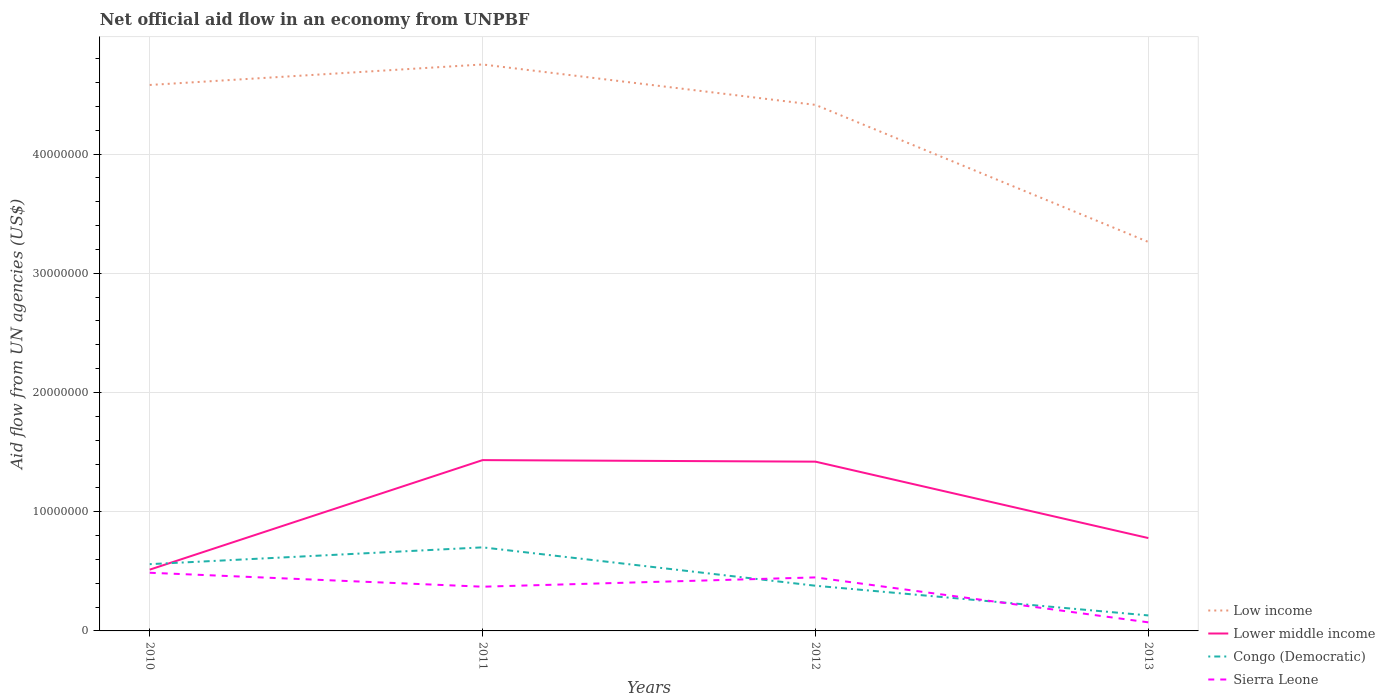Does the line corresponding to Lower middle income intersect with the line corresponding to Congo (Democratic)?
Your answer should be very brief. Yes. Is the number of lines equal to the number of legend labels?
Give a very brief answer. Yes. Across all years, what is the maximum net official aid flow in Sierra Leone?
Ensure brevity in your answer.  7.20e+05. What is the total net official aid flow in Lower middle income in the graph?
Provide a succinct answer. 6.54e+06. What is the difference between the highest and the second highest net official aid flow in Congo (Democratic)?
Offer a very short reply. 5.71e+06. Does the graph contain any zero values?
Provide a short and direct response. No. Does the graph contain grids?
Ensure brevity in your answer.  Yes. How many legend labels are there?
Offer a very short reply. 4. What is the title of the graph?
Provide a short and direct response. Net official aid flow in an economy from UNPBF. What is the label or title of the Y-axis?
Provide a short and direct response. Aid flow from UN agencies (US$). What is the Aid flow from UN agencies (US$) in Low income in 2010?
Make the answer very short. 4.58e+07. What is the Aid flow from UN agencies (US$) of Lower middle income in 2010?
Your response must be concise. 5.14e+06. What is the Aid flow from UN agencies (US$) in Congo (Democratic) in 2010?
Keep it short and to the point. 5.60e+06. What is the Aid flow from UN agencies (US$) in Sierra Leone in 2010?
Keep it short and to the point. 4.88e+06. What is the Aid flow from UN agencies (US$) of Low income in 2011?
Provide a short and direct response. 4.75e+07. What is the Aid flow from UN agencies (US$) of Lower middle income in 2011?
Ensure brevity in your answer.  1.43e+07. What is the Aid flow from UN agencies (US$) in Congo (Democratic) in 2011?
Provide a short and direct response. 7.01e+06. What is the Aid flow from UN agencies (US$) in Sierra Leone in 2011?
Offer a very short reply. 3.71e+06. What is the Aid flow from UN agencies (US$) of Low income in 2012?
Keep it short and to the point. 4.41e+07. What is the Aid flow from UN agencies (US$) in Lower middle income in 2012?
Provide a short and direct response. 1.42e+07. What is the Aid flow from UN agencies (US$) in Congo (Democratic) in 2012?
Offer a terse response. 3.79e+06. What is the Aid flow from UN agencies (US$) in Sierra Leone in 2012?
Offer a terse response. 4.49e+06. What is the Aid flow from UN agencies (US$) of Low income in 2013?
Your response must be concise. 3.26e+07. What is the Aid flow from UN agencies (US$) of Lower middle income in 2013?
Your response must be concise. 7.79e+06. What is the Aid flow from UN agencies (US$) of Congo (Democratic) in 2013?
Provide a succinct answer. 1.30e+06. What is the Aid flow from UN agencies (US$) of Sierra Leone in 2013?
Give a very brief answer. 7.20e+05. Across all years, what is the maximum Aid flow from UN agencies (US$) of Low income?
Your answer should be compact. 4.75e+07. Across all years, what is the maximum Aid flow from UN agencies (US$) of Lower middle income?
Your answer should be very brief. 1.43e+07. Across all years, what is the maximum Aid flow from UN agencies (US$) of Congo (Democratic)?
Your answer should be very brief. 7.01e+06. Across all years, what is the maximum Aid flow from UN agencies (US$) in Sierra Leone?
Offer a terse response. 4.88e+06. Across all years, what is the minimum Aid flow from UN agencies (US$) in Low income?
Keep it short and to the point. 3.26e+07. Across all years, what is the minimum Aid flow from UN agencies (US$) of Lower middle income?
Give a very brief answer. 5.14e+06. Across all years, what is the minimum Aid flow from UN agencies (US$) in Congo (Democratic)?
Provide a short and direct response. 1.30e+06. Across all years, what is the minimum Aid flow from UN agencies (US$) of Sierra Leone?
Offer a very short reply. 7.20e+05. What is the total Aid flow from UN agencies (US$) of Low income in the graph?
Keep it short and to the point. 1.70e+08. What is the total Aid flow from UN agencies (US$) in Lower middle income in the graph?
Give a very brief answer. 4.15e+07. What is the total Aid flow from UN agencies (US$) in Congo (Democratic) in the graph?
Give a very brief answer. 1.77e+07. What is the total Aid flow from UN agencies (US$) of Sierra Leone in the graph?
Give a very brief answer. 1.38e+07. What is the difference between the Aid flow from UN agencies (US$) in Low income in 2010 and that in 2011?
Your response must be concise. -1.72e+06. What is the difference between the Aid flow from UN agencies (US$) of Lower middle income in 2010 and that in 2011?
Provide a short and direct response. -9.19e+06. What is the difference between the Aid flow from UN agencies (US$) of Congo (Democratic) in 2010 and that in 2011?
Offer a terse response. -1.41e+06. What is the difference between the Aid flow from UN agencies (US$) in Sierra Leone in 2010 and that in 2011?
Your answer should be compact. 1.17e+06. What is the difference between the Aid flow from UN agencies (US$) of Low income in 2010 and that in 2012?
Ensure brevity in your answer.  1.67e+06. What is the difference between the Aid flow from UN agencies (US$) in Lower middle income in 2010 and that in 2012?
Keep it short and to the point. -9.06e+06. What is the difference between the Aid flow from UN agencies (US$) of Congo (Democratic) in 2010 and that in 2012?
Offer a terse response. 1.81e+06. What is the difference between the Aid flow from UN agencies (US$) in Low income in 2010 and that in 2013?
Offer a very short reply. 1.32e+07. What is the difference between the Aid flow from UN agencies (US$) of Lower middle income in 2010 and that in 2013?
Your response must be concise. -2.65e+06. What is the difference between the Aid flow from UN agencies (US$) in Congo (Democratic) in 2010 and that in 2013?
Offer a terse response. 4.30e+06. What is the difference between the Aid flow from UN agencies (US$) of Sierra Leone in 2010 and that in 2013?
Your answer should be compact. 4.16e+06. What is the difference between the Aid flow from UN agencies (US$) in Low income in 2011 and that in 2012?
Offer a terse response. 3.39e+06. What is the difference between the Aid flow from UN agencies (US$) of Lower middle income in 2011 and that in 2012?
Provide a succinct answer. 1.30e+05. What is the difference between the Aid flow from UN agencies (US$) in Congo (Democratic) in 2011 and that in 2012?
Give a very brief answer. 3.22e+06. What is the difference between the Aid flow from UN agencies (US$) in Sierra Leone in 2011 and that in 2012?
Your answer should be very brief. -7.80e+05. What is the difference between the Aid flow from UN agencies (US$) of Low income in 2011 and that in 2013?
Your answer should be very brief. 1.49e+07. What is the difference between the Aid flow from UN agencies (US$) of Lower middle income in 2011 and that in 2013?
Ensure brevity in your answer.  6.54e+06. What is the difference between the Aid flow from UN agencies (US$) in Congo (Democratic) in 2011 and that in 2013?
Provide a short and direct response. 5.71e+06. What is the difference between the Aid flow from UN agencies (US$) in Sierra Leone in 2011 and that in 2013?
Your response must be concise. 2.99e+06. What is the difference between the Aid flow from UN agencies (US$) of Low income in 2012 and that in 2013?
Make the answer very short. 1.15e+07. What is the difference between the Aid flow from UN agencies (US$) of Lower middle income in 2012 and that in 2013?
Offer a terse response. 6.41e+06. What is the difference between the Aid flow from UN agencies (US$) in Congo (Democratic) in 2012 and that in 2013?
Offer a very short reply. 2.49e+06. What is the difference between the Aid flow from UN agencies (US$) of Sierra Leone in 2012 and that in 2013?
Provide a short and direct response. 3.77e+06. What is the difference between the Aid flow from UN agencies (US$) of Low income in 2010 and the Aid flow from UN agencies (US$) of Lower middle income in 2011?
Your answer should be compact. 3.15e+07. What is the difference between the Aid flow from UN agencies (US$) in Low income in 2010 and the Aid flow from UN agencies (US$) in Congo (Democratic) in 2011?
Keep it short and to the point. 3.88e+07. What is the difference between the Aid flow from UN agencies (US$) in Low income in 2010 and the Aid flow from UN agencies (US$) in Sierra Leone in 2011?
Offer a terse response. 4.21e+07. What is the difference between the Aid flow from UN agencies (US$) in Lower middle income in 2010 and the Aid flow from UN agencies (US$) in Congo (Democratic) in 2011?
Make the answer very short. -1.87e+06. What is the difference between the Aid flow from UN agencies (US$) in Lower middle income in 2010 and the Aid flow from UN agencies (US$) in Sierra Leone in 2011?
Offer a terse response. 1.43e+06. What is the difference between the Aid flow from UN agencies (US$) in Congo (Democratic) in 2010 and the Aid flow from UN agencies (US$) in Sierra Leone in 2011?
Ensure brevity in your answer.  1.89e+06. What is the difference between the Aid flow from UN agencies (US$) of Low income in 2010 and the Aid flow from UN agencies (US$) of Lower middle income in 2012?
Give a very brief answer. 3.16e+07. What is the difference between the Aid flow from UN agencies (US$) of Low income in 2010 and the Aid flow from UN agencies (US$) of Congo (Democratic) in 2012?
Make the answer very short. 4.20e+07. What is the difference between the Aid flow from UN agencies (US$) of Low income in 2010 and the Aid flow from UN agencies (US$) of Sierra Leone in 2012?
Ensure brevity in your answer.  4.13e+07. What is the difference between the Aid flow from UN agencies (US$) of Lower middle income in 2010 and the Aid flow from UN agencies (US$) of Congo (Democratic) in 2012?
Make the answer very short. 1.35e+06. What is the difference between the Aid flow from UN agencies (US$) in Lower middle income in 2010 and the Aid flow from UN agencies (US$) in Sierra Leone in 2012?
Your answer should be compact. 6.50e+05. What is the difference between the Aid flow from UN agencies (US$) in Congo (Democratic) in 2010 and the Aid flow from UN agencies (US$) in Sierra Leone in 2012?
Your answer should be compact. 1.11e+06. What is the difference between the Aid flow from UN agencies (US$) in Low income in 2010 and the Aid flow from UN agencies (US$) in Lower middle income in 2013?
Provide a short and direct response. 3.80e+07. What is the difference between the Aid flow from UN agencies (US$) in Low income in 2010 and the Aid flow from UN agencies (US$) in Congo (Democratic) in 2013?
Your answer should be compact. 4.45e+07. What is the difference between the Aid flow from UN agencies (US$) in Low income in 2010 and the Aid flow from UN agencies (US$) in Sierra Leone in 2013?
Give a very brief answer. 4.51e+07. What is the difference between the Aid flow from UN agencies (US$) in Lower middle income in 2010 and the Aid flow from UN agencies (US$) in Congo (Democratic) in 2013?
Give a very brief answer. 3.84e+06. What is the difference between the Aid flow from UN agencies (US$) of Lower middle income in 2010 and the Aid flow from UN agencies (US$) of Sierra Leone in 2013?
Provide a short and direct response. 4.42e+06. What is the difference between the Aid flow from UN agencies (US$) in Congo (Democratic) in 2010 and the Aid flow from UN agencies (US$) in Sierra Leone in 2013?
Your answer should be compact. 4.88e+06. What is the difference between the Aid flow from UN agencies (US$) of Low income in 2011 and the Aid flow from UN agencies (US$) of Lower middle income in 2012?
Your answer should be compact. 3.33e+07. What is the difference between the Aid flow from UN agencies (US$) in Low income in 2011 and the Aid flow from UN agencies (US$) in Congo (Democratic) in 2012?
Ensure brevity in your answer.  4.37e+07. What is the difference between the Aid flow from UN agencies (US$) of Low income in 2011 and the Aid flow from UN agencies (US$) of Sierra Leone in 2012?
Ensure brevity in your answer.  4.30e+07. What is the difference between the Aid flow from UN agencies (US$) of Lower middle income in 2011 and the Aid flow from UN agencies (US$) of Congo (Democratic) in 2012?
Offer a terse response. 1.05e+07. What is the difference between the Aid flow from UN agencies (US$) in Lower middle income in 2011 and the Aid flow from UN agencies (US$) in Sierra Leone in 2012?
Ensure brevity in your answer.  9.84e+06. What is the difference between the Aid flow from UN agencies (US$) in Congo (Democratic) in 2011 and the Aid flow from UN agencies (US$) in Sierra Leone in 2012?
Give a very brief answer. 2.52e+06. What is the difference between the Aid flow from UN agencies (US$) of Low income in 2011 and the Aid flow from UN agencies (US$) of Lower middle income in 2013?
Ensure brevity in your answer.  3.97e+07. What is the difference between the Aid flow from UN agencies (US$) of Low income in 2011 and the Aid flow from UN agencies (US$) of Congo (Democratic) in 2013?
Provide a short and direct response. 4.62e+07. What is the difference between the Aid flow from UN agencies (US$) in Low income in 2011 and the Aid flow from UN agencies (US$) in Sierra Leone in 2013?
Provide a succinct answer. 4.68e+07. What is the difference between the Aid flow from UN agencies (US$) in Lower middle income in 2011 and the Aid flow from UN agencies (US$) in Congo (Democratic) in 2013?
Give a very brief answer. 1.30e+07. What is the difference between the Aid flow from UN agencies (US$) of Lower middle income in 2011 and the Aid flow from UN agencies (US$) of Sierra Leone in 2013?
Make the answer very short. 1.36e+07. What is the difference between the Aid flow from UN agencies (US$) in Congo (Democratic) in 2011 and the Aid flow from UN agencies (US$) in Sierra Leone in 2013?
Make the answer very short. 6.29e+06. What is the difference between the Aid flow from UN agencies (US$) of Low income in 2012 and the Aid flow from UN agencies (US$) of Lower middle income in 2013?
Your answer should be very brief. 3.63e+07. What is the difference between the Aid flow from UN agencies (US$) in Low income in 2012 and the Aid flow from UN agencies (US$) in Congo (Democratic) in 2013?
Give a very brief answer. 4.28e+07. What is the difference between the Aid flow from UN agencies (US$) in Low income in 2012 and the Aid flow from UN agencies (US$) in Sierra Leone in 2013?
Keep it short and to the point. 4.34e+07. What is the difference between the Aid flow from UN agencies (US$) in Lower middle income in 2012 and the Aid flow from UN agencies (US$) in Congo (Democratic) in 2013?
Provide a short and direct response. 1.29e+07. What is the difference between the Aid flow from UN agencies (US$) in Lower middle income in 2012 and the Aid flow from UN agencies (US$) in Sierra Leone in 2013?
Your response must be concise. 1.35e+07. What is the difference between the Aid flow from UN agencies (US$) of Congo (Democratic) in 2012 and the Aid flow from UN agencies (US$) of Sierra Leone in 2013?
Your answer should be compact. 3.07e+06. What is the average Aid flow from UN agencies (US$) in Low income per year?
Your answer should be very brief. 4.25e+07. What is the average Aid flow from UN agencies (US$) of Lower middle income per year?
Ensure brevity in your answer.  1.04e+07. What is the average Aid flow from UN agencies (US$) of Congo (Democratic) per year?
Your answer should be very brief. 4.42e+06. What is the average Aid flow from UN agencies (US$) in Sierra Leone per year?
Make the answer very short. 3.45e+06. In the year 2010, what is the difference between the Aid flow from UN agencies (US$) in Low income and Aid flow from UN agencies (US$) in Lower middle income?
Ensure brevity in your answer.  4.07e+07. In the year 2010, what is the difference between the Aid flow from UN agencies (US$) in Low income and Aid flow from UN agencies (US$) in Congo (Democratic)?
Your answer should be very brief. 4.02e+07. In the year 2010, what is the difference between the Aid flow from UN agencies (US$) of Low income and Aid flow from UN agencies (US$) of Sierra Leone?
Keep it short and to the point. 4.09e+07. In the year 2010, what is the difference between the Aid flow from UN agencies (US$) in Lower middle income and Aid flow from UN agencies (US$) in Congo (Democratic)?
Your answer should be very brief. -4.60e+05. In the year 2010, what is the difference between the Aid flow from UN agencies (US$) of Congo (Democratic) and Aid flow from UN agencies (US$) of Sierra Leone?
Offer a very short reply. 7.20e+05. In the year 2011, what is the difference between the Aid flow from UN agencies (US$) in Low income and Aid flow from UN agencies (US$) in Lower middle income?
Your response must be concise. 3.32e+07. In the year 2011, what is the difference between the Aid flow from UN agencies (US$) in Low income and Aid flow from UN agencies (US$) in Congo (Democratic)?
Offer a terse response. 4.05e+07. In the year 2011, what is the difference between the Aid flow from UN agencies (US$) in Low income and Aid flow from UN agencies (US$) in Sierra Leone?
Give a very brief answer. 4.38e+07. In the year 2011, what is the difference between the Aid flow from UN agencies (US$) in Lower middle income and Aid flow from UN agencies (US$) in Congo (Democratic)?
Offer a very short reply. 7.32e+06. In the year 2011, what is the difference between the Aid flow from UN agencies (US$) of Lower middle income and Aid flow from UN agencies (US$) of Sierra Leone?
Your answer should be compact. 1.06e+07. In the year 2011, what is the difference between the Aid flow from UN agencies (US$) of Congo (Democratic) and Aid flow from UN agencies (US$) of Sierra Leone?
Make the answer very short. 3.30e+06. In the year 2012, what is the difference between the Aid flow from UN agencies (US$) in Low income and Aid flow from UN agencies (US$) in Lower middle income?
Offer a terse response. 2.99e+07. In the year 2012, what is the difference between the Aid flow from UN agencies (US$) of Low income and Aid flow from UN agencies (US$) of Congo (Democratic)?
Make the answer very short. 4.03e+07. In the year 2012, what is the difference between the Aid flow from UN agencies (US$) of Low income and Aid flow from UN agencies (US$) of Sierra Leone?
Your answer should be compact. 3.96e+07. In the year 2012, what is the difference between the Aid flow from UN agencies (US$) in Lower middle income and Aid flow from UN agencies (US$) in Congo (Democratic)?
Make the answer very short. 1.04e+07. In the year 2012, what is the difference between the Aid flow from UN agencies (US$) in Lower middle income and Aid flow from UN agencies (US$) in Sierra Leone?
Make the answer very short. 9.71e+06. In the year 2012, what is the difference between the Aid flow from UN agencies (US$) in Congo (Democratic) and Aid flow from UN agencies (US$) in Sierra Leone?
Keep it short and to the point. -7.00e+05. In the year 2013, what is the difference between the Aid flow from UN agencies (US$) of Low income and Aid flow from UN agencies (US$) of Lower middle income?
Offer a very short reply. 2.48e+07. In the year 2013, what is the difference between the Aid flow from UN agencies (US$) in Low income and Aid flow from UN agencies (US$) in Congo (Democratic)?
Your answer should be compact. 3.13e+07. In the year 2013, what is the difference between the Aid flow from UN agencies (US$) of Low income and Aid flow from UN agencies (US$) of Sierra Leone?
Give a very brief answer. 3.19e+07. In the year 2013, what is the difference between the Aid flow from UN agencies (US$) in Lower middle income and Aid flow from UN agencies (US$) in Congo (Democratic)?
Your answer should be compact. 6.49e+06. In the year 2013, what is the difference between the Aid flow from UN agencies (US$) in Lower middle income and Aid flow from UN agencies (US$) in Sierra Leone?
Offer a terse response. 7.07e+06. In the year 2013, what is the difference between the Aid flow from UN agencies (US$) of Congo (Democratic) and Aid flow from UN agencies (US$) of Sierra Leone?
Your answer should be compact. 5.80e+05. What is the ratio of the Aid flow from UN agencies (US$) of Low income in 2010 to that in 2011?
Provide a short and direct response. 0.96. What is the ratio of the Aid flow from UN agencies (US$) in Lower middle income in 2010 to that in 2011?
Offer a terse response. 0.36. What is the ratio of the Aid flow from UN agencies (US$) in Congo (Democratic) in 2010 to that in 2011?
Ensure brevity in your answer.  0.8. What is the ratio of the Aid flow from UN agencies (US$) of Sierra Leone in 2010 to that in 2011?
Your answer should be very brief. 1.32. What is the ratio of the Aid flow from UN agencies (US$) in Low income in 2010 to that in 2012?
Your answer should be compact. 1.04. What is the ratio of the Aid flow from UN agencies (US$) in Lower middle income in 2010 to that in 2012?
Offer a very short reply. 0.36. What is the ratio of the Aid flow from UN agencies (US$) in Congo (Democratic) in 2010 to that in 2012?
Offer a terse response. 1.48. What is the ratio of the Aid flow from UN agencies (US$) in Sierra Leone in 2010 to that in 2012?
Provide a succinct answer. 1.09. What is the ratio of the Aid flow from UN agencies (US$) in Low income in 2010 to that in 2013?
Give a very brief answer. 1.4. What is the ratio of the Aid flow from UN agencies (US$) of Lower middle income in 2010 to that in 2013?
Give a very brief answer. 0.66. What is the ratio of the Aid flow from UN agencies (US$) in Congo (Democratic) in 2010 to that in 2013?
Your answer should be very brief. 4.31. What is the ratio of the Aid flow from UN agencies (US$) of Sierra Leone in 2010 to that in 2013?
Give a very brief answer. 6.78. What is the ratio of the Aid flow from UN agencies (US$) of Low income in 2011 to that in 2012?
Your response must be concise. 1.08. What is the ratio of the Aid flow from UN agencies (US$) in Lower middle income in 2011 to that in 2012?
Your response must be concise. 1.01. What is the ratio of the Aid flow from UN agencies (US$) of Congo (Democratic) in 2011 to that in 2012?
Provide a succinct answer. 1.85. What is the ratio of the Aid flow from UN agencies (US$) in Sierra Leone in 2011 to that in 2012?
Ensure brevity in your answer.  0.83. What is the ratio of the Aid flow from UN agencies (US$) of Low income in 2011 to that in 2013?
Provide a short and direct response. 1.46. What is the ratio of the Aid flow from UN agencies (US$) of Lower middle income in 2011 to that in 2013?
Ensure brevity in your answer.  1.84. What is the ratio of the Aid flow from UN agencies (US$) of Congo (Democratic) in 2011 to that in 2013?
Make the answer very short. 5.39. What is the ratio of the Aid flow from UN agencies (US$) in Sierra Leone in 2011 to that in 2013?
Your answer should be very brief. 5.15. What is the ratio of the Aid flow from UN agencies (US$) in Low income in 2012 to that in 2013?
Provide a short and direct response. 1.35. What is the ratio of the Aid flow from UN agencies (US$) of Lower middle income in 2012 to that in 2013?
Provide a short and direct response. 1.82. What is the ratio of the Aid flow from UN agencies (US$) of Congo (Democratic) in 2012 to that in 2013?
Your response must be concise. 2.92. What is the ratio of the Aid flow from UN agencies (US$) of Sierra Leone in 2012 to that in 2013?
Your answer should be compact. 6.24. What is the difference between the highest and the second highest Aid flow from UN agencies (US$) in Low income?
Give a very brief answer. 1.72e+06. What is the difference between the highest and the second highest Aid flow from UN agencies (US$) of Congo (Democratic)?
Your answer should be compact. 1.41e+06. What is the difference between the highest and the lowest Aid flow from UN agencies (US$) in Low income?
Your answer should be compact. 1.49e+07. What is the difference between the highest and the lowest Aid flow from UN agencies (US$) of Lower middle income?
Make the answer very short. 9.19e+06. What is the difference between the highest and the lowest Aid flow from UN agencies (US$) in Congo (Democratic)?
Make the answer very short. 5.71e+06. What is the difference between the highest and the lowest Aid flow from UN agencies (US$) in Sierra Leone?
Keep it short and to the point. 4.16e+06. 